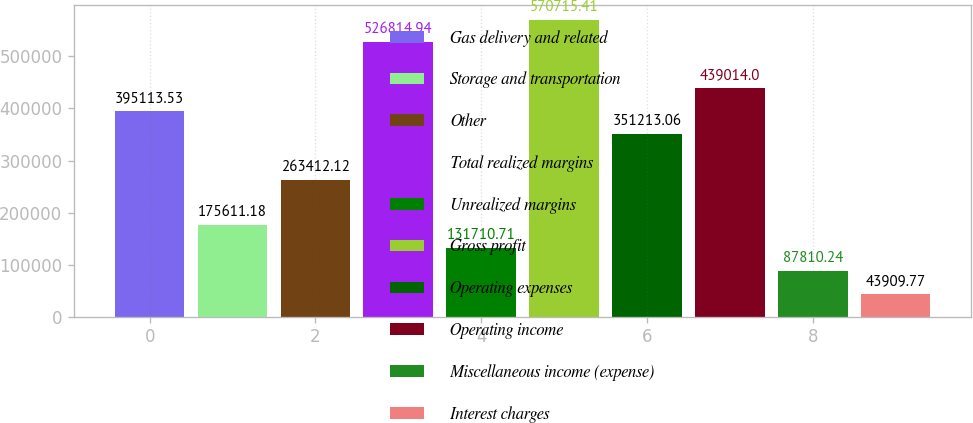Convert chart to OTSL. <chart><loc_0><loc_0><loc_500><loc_500><bar_chart><fcel>Gas delivery and related<fcel>Storage and transportation<fcel>Other<fcel>Total realized margins<fcel>Unrealized margins<fcel>Gross profit<fcel>Operating expenses<fcel>Operating income<fcel>Miscellaneous income (expense)<fcel>Interest charges<nl><fcel>395114<fcel>175611<fcel>263412<fcel>526815<fcel>131711<fcel>570715<fcel>351213<fcel>439014<fcel>87810.2<fcel>43909.8<nl></chart> 